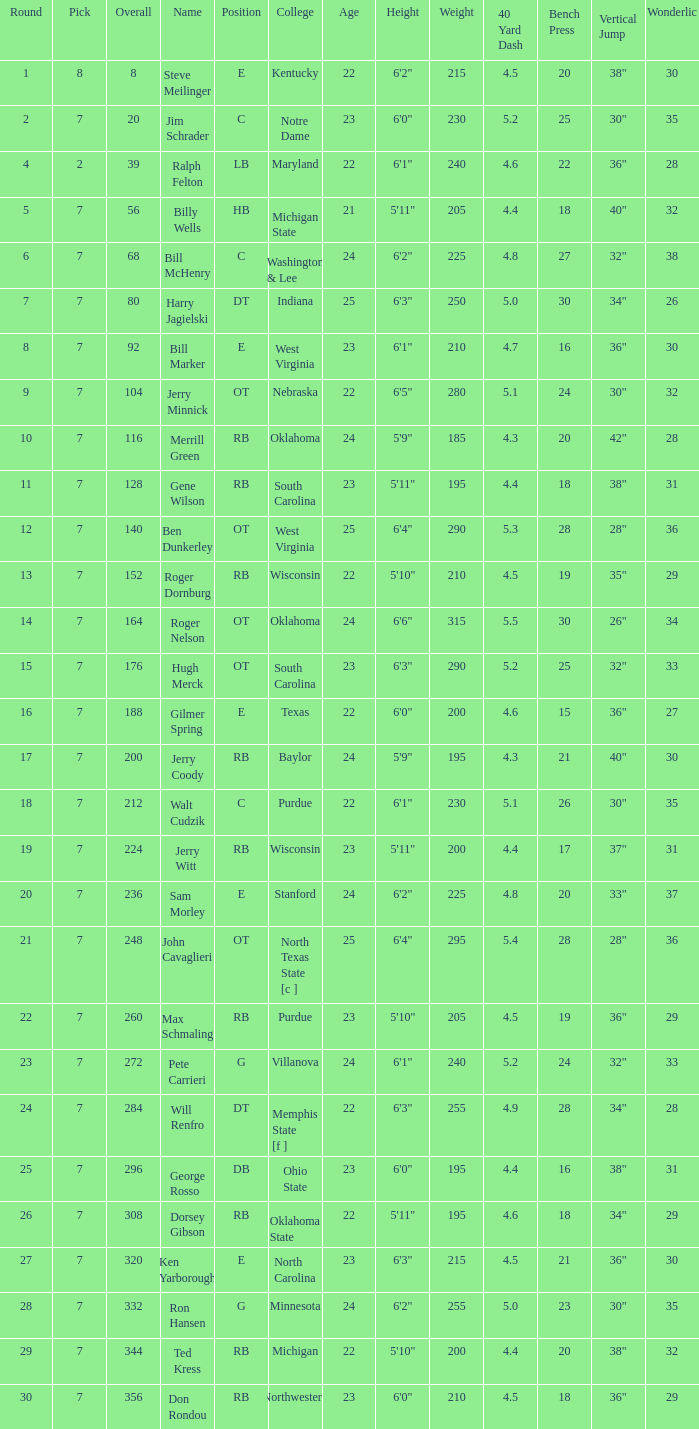What pick did George Rosso get drafted when the overall was less than 296? 0.0. 